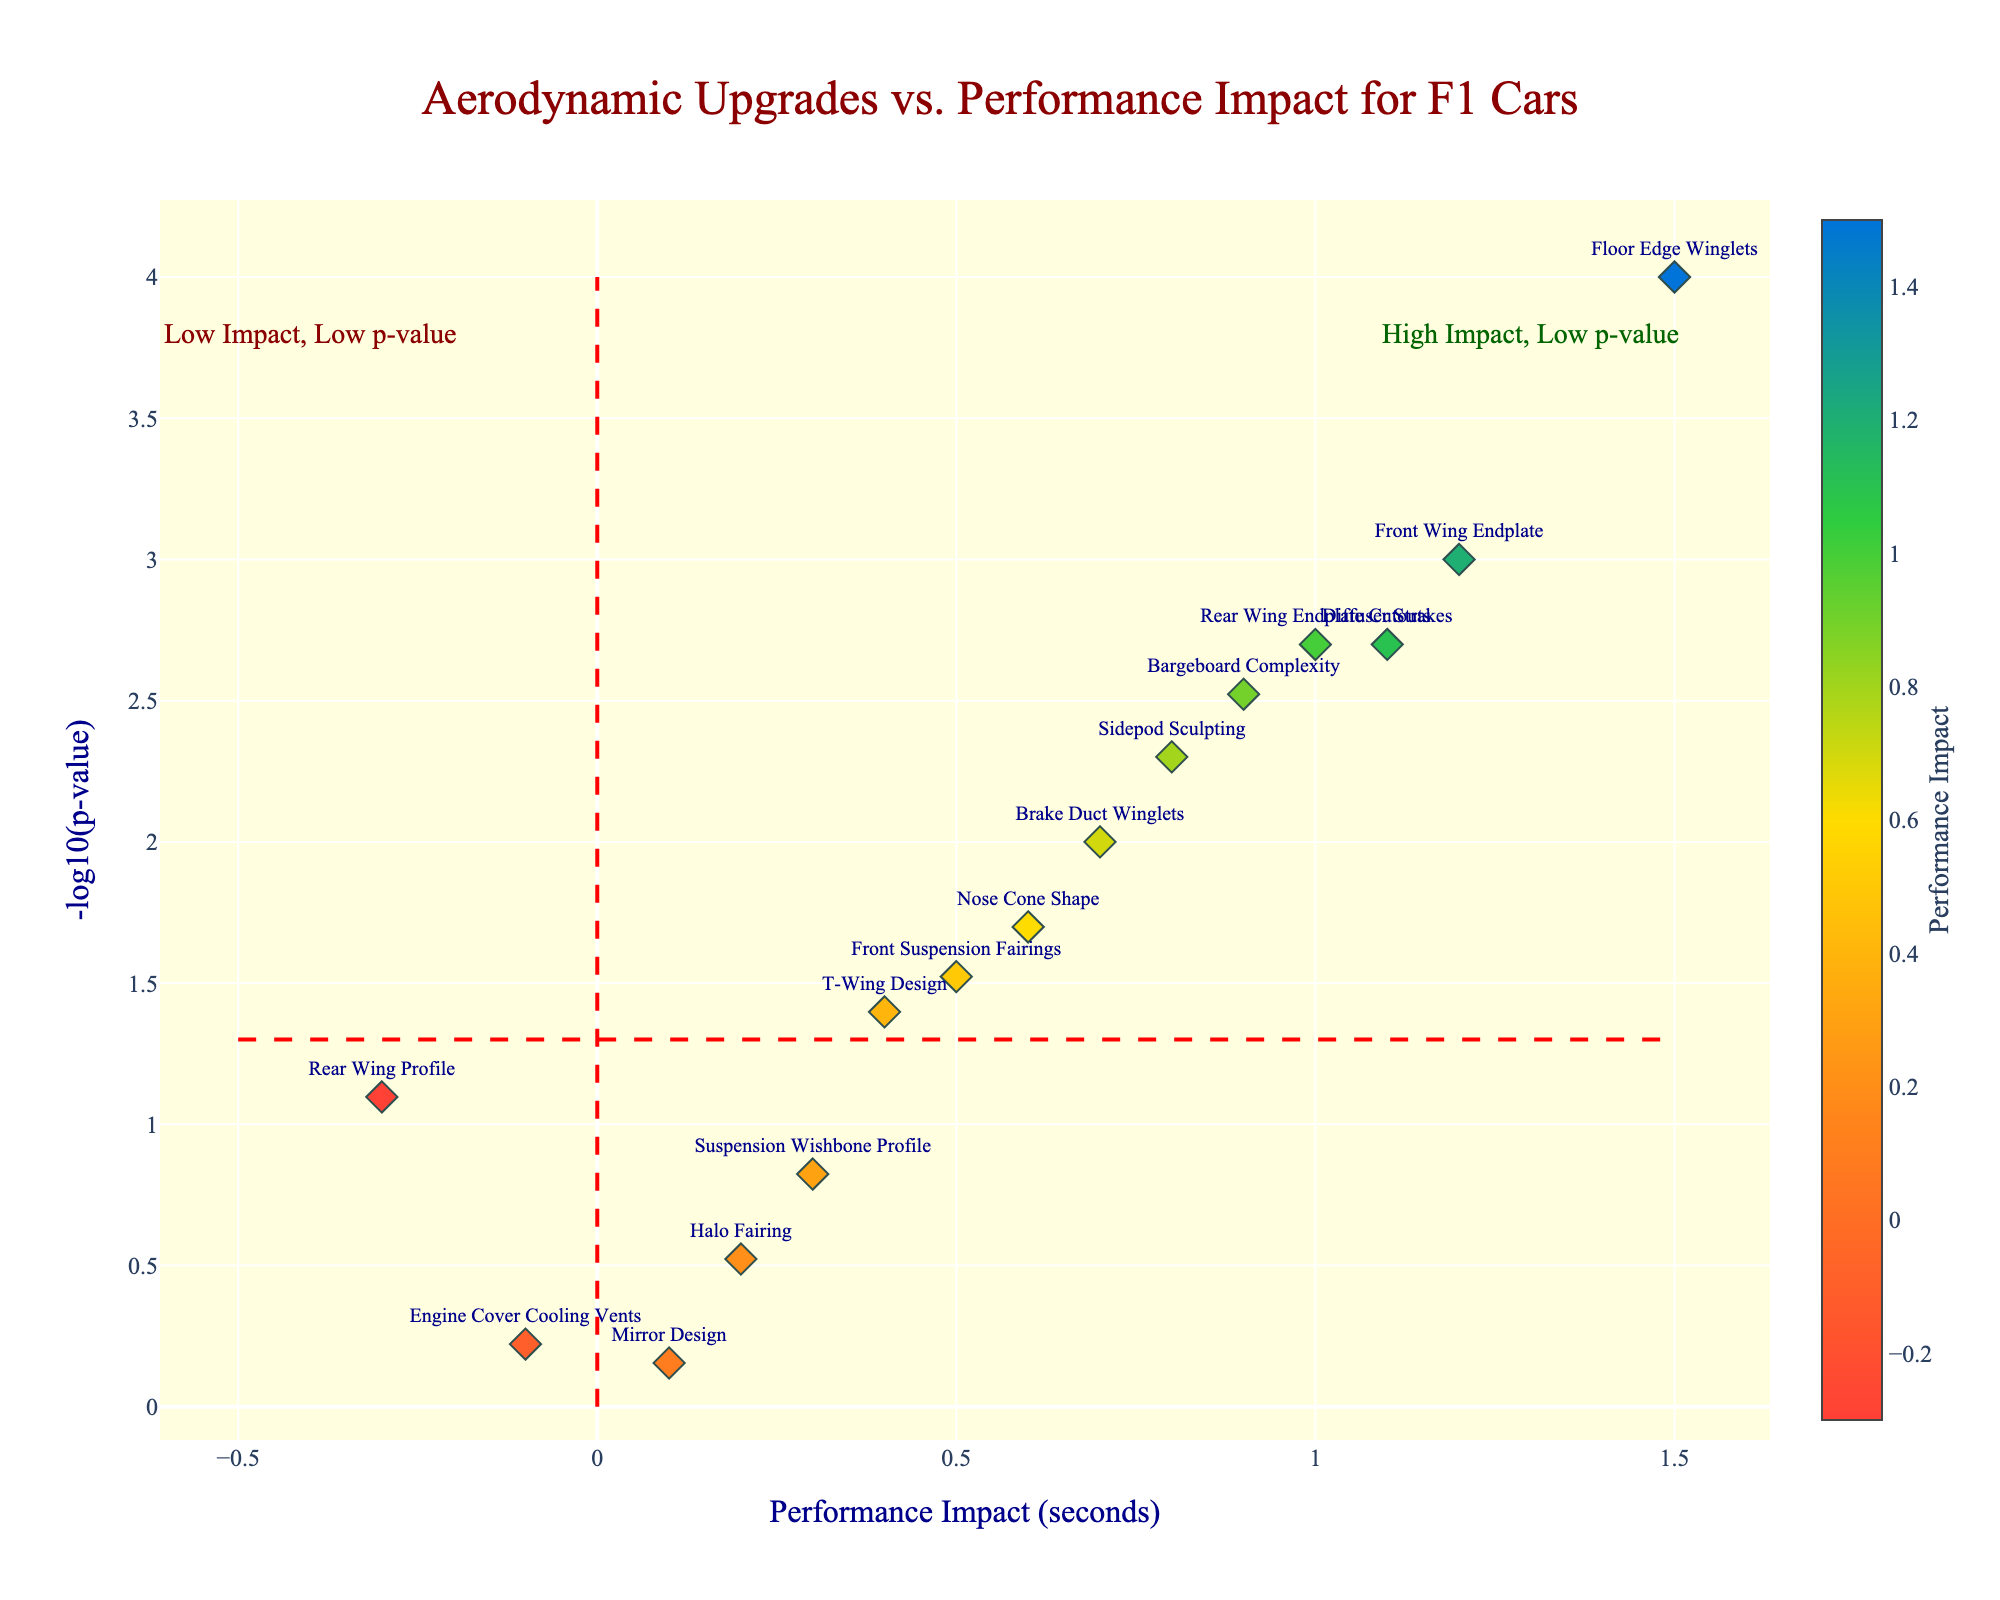Which aerodynamic upgrade shows the highest performance impact? To find the highest performance impact, look for the point farthest to the right on the x-axis labeled 'Performance Impact'. The 'Floor Edge Winglets' is at 1.5, which is the furthest to the right.
Answer: Floor Edge Winglets Which upgrade has the most statistically significant impact on performance? Statistically significant is indicated by the highest -log10(p-value). The highest point on the y-axis is 'Floor Edge Winglets' with a -log10(p-value) close to 4.
Answer: Floor Edge Winglets How many upgrades have a performance impact greater than 1 second? Count the points to the right of the vertical line at 1. There are three: 'Front Wing Endplate', 'Floor Edge Winglets', and 'Rear Wing Endplate Cutouts'.
Answer: 3 What is the combined performance impact of 'Bargeboard Complexity' and 'Nose Cone Shape'? Find the performance impact for both upgrades. Bargeboard Complexity is at 0.9 and Nose Cone Shape at 0.6. Sum these values: 0.9 + 0.6 = 1.5.
Answer: 1.5 What are the performance impacts of 'Engine Cover Cooling Vents' and 'Mirror Design', and which is the lower of the two? The performance impacts are shown on the x-axis. Engine Cover Cooling Vents is at -0.1, and Mirror Design is at 0.1. The lower impact is -0.1.
Answer: -0.1 Which aerodynamic upgrade has the least statistically significant impact on performance? The least statistically significant upgrade will be the one with the lowest -log10(p-value). 'Mirror Design' has a -log10(p-value) of around 0.2, the lowest in the plot.
Answer: Mirror Design Compare the 'Front Suspension Fairings' and 'Rear Wing Profile' in terms of both performance impact and statistical significance. Which one is better? 'Front Suspension Fairings' has a performance impact of 0.5 and a -log10(p-value) of around 1.5. 'Rear Wing Profile' has a performance impact of -0.3 and a -log10(p-value) of about 1.1. A better upgrade should have a higher performance impact and lower p-value; thus, 'Front Suspension Fairings' is better.
Answer: Front Suspension Fairings What is the statistical significance level (-log10(p-value)) set as the threshold in the plot? The threshold for statistical significance can be identified by the horizontal dashed red line, which is drawn at around -log10(p-value)=1.3.
Answer: 1.3 